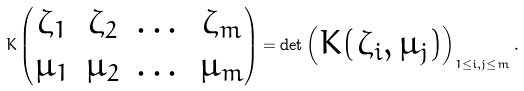<formula> <loc_0><loc_0><loc_500><loc_500>K \begin{pmatrix} \zeta _ { 1 } & \zeta _ { 2 } & \dots & \zeta _ { m } \\ \mu _ { 1 } & \mu _ { 2 } & \dots & \mu _ { m } \end{pmatrix} = \det \begin{pmatrix} K ( \zeta _ { i } , \mu _ { j } ) \end{pmatrix} _ { 1 \leq i , j \leq m } .</formula> 